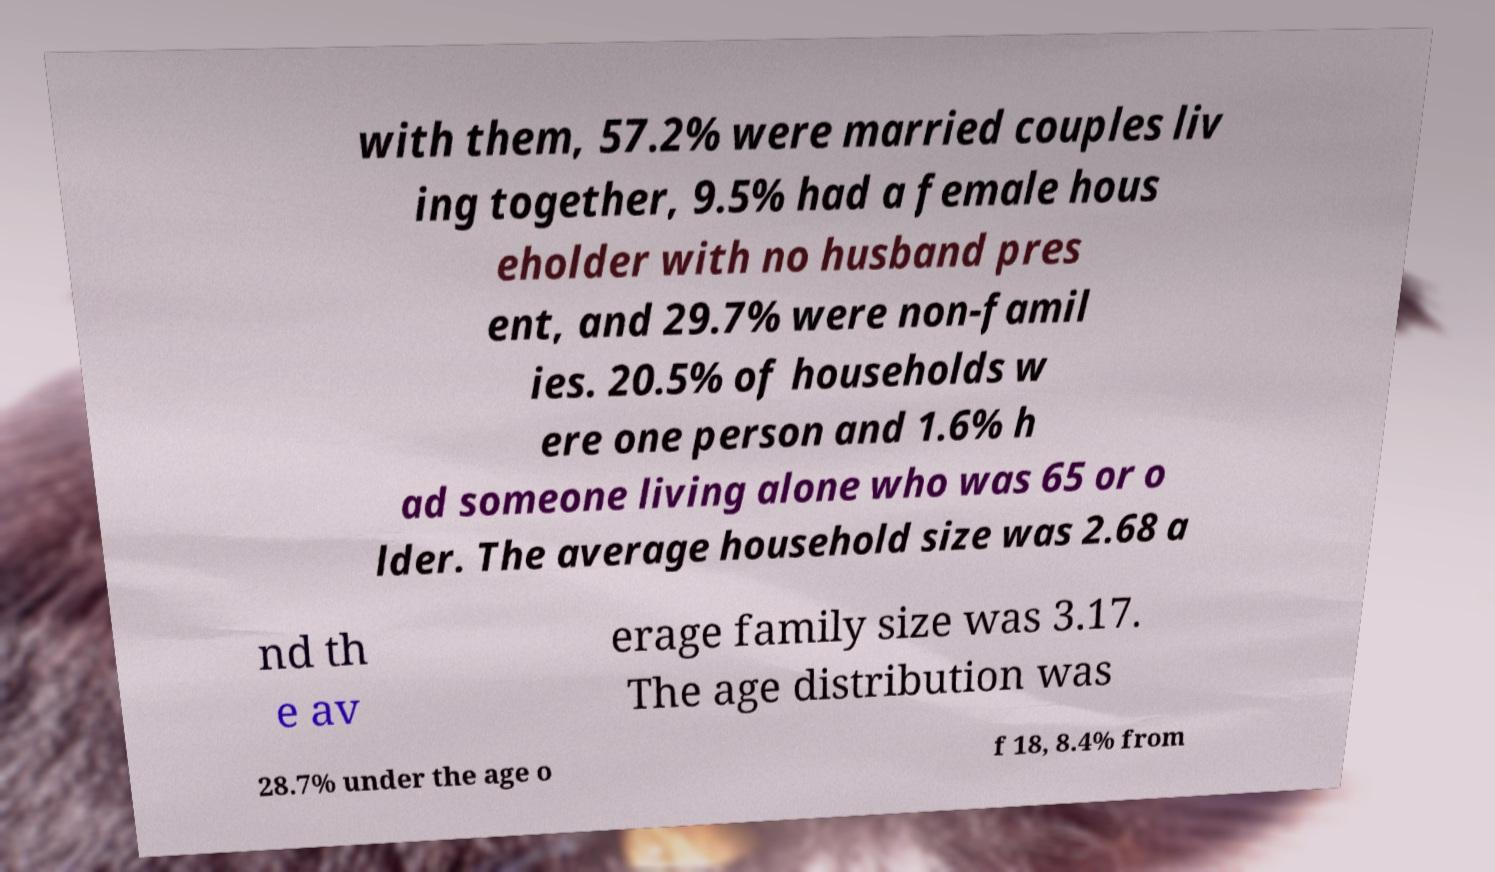Can you read and provide the text displayed in the image?This photo seems to have some interesting text. Can you extract and type it out for me? with them, 57.2% were married couples liv ing together, 9.5% had a female hous eholder with no husband pres ent, and 29.7% were non-famil ies. 20.5% of households w ere one person and 1.6% h ad someone living alone who was 65 or o lder. The average household size was 2.68 a nd th e av erage family size was 3.17. The age distribution was 28.7% under the age o f 18, 8.4% from 